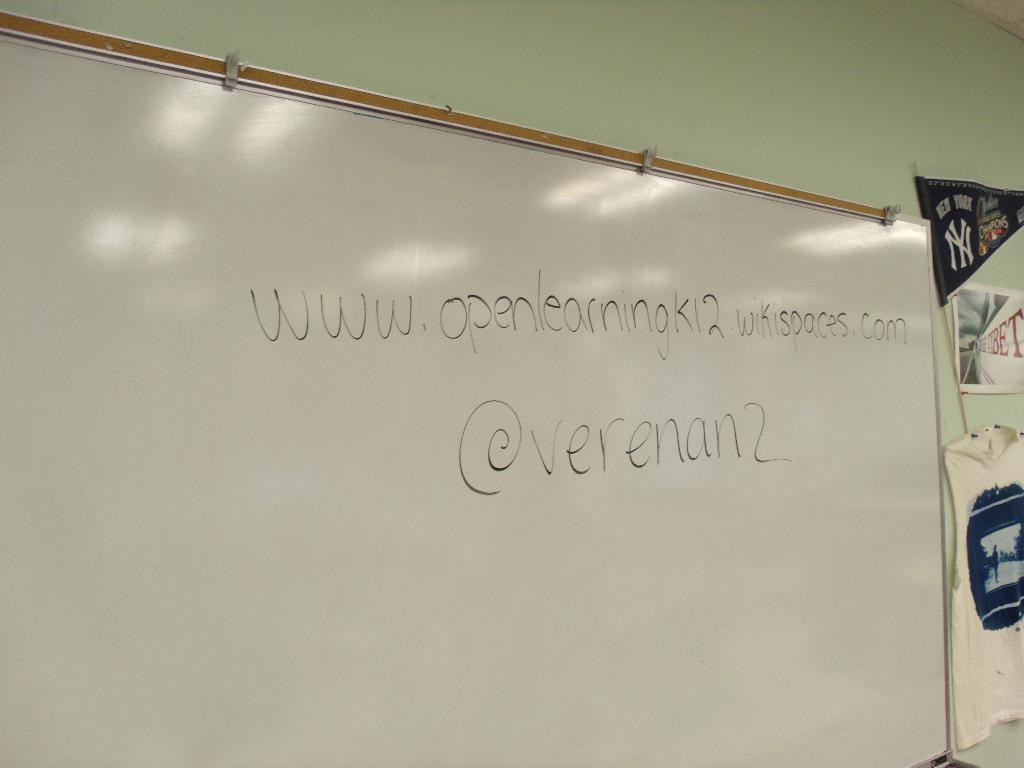Provide a one-sentence caption for the provided image. a white board with black writing from @verenan2. 